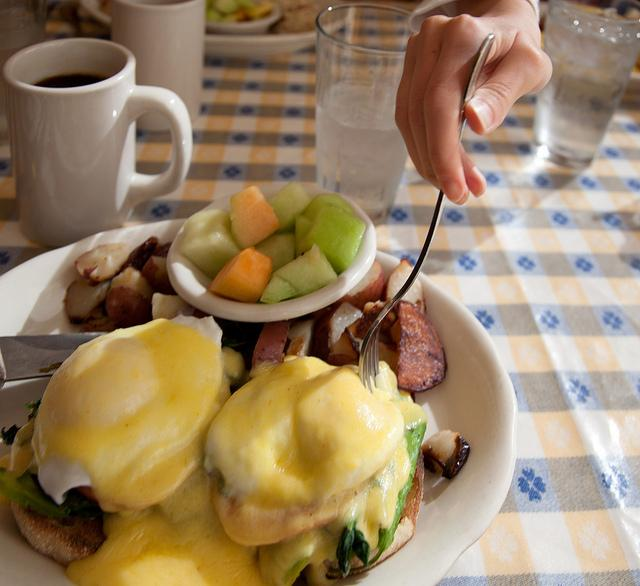What is in the small plate? fruit 